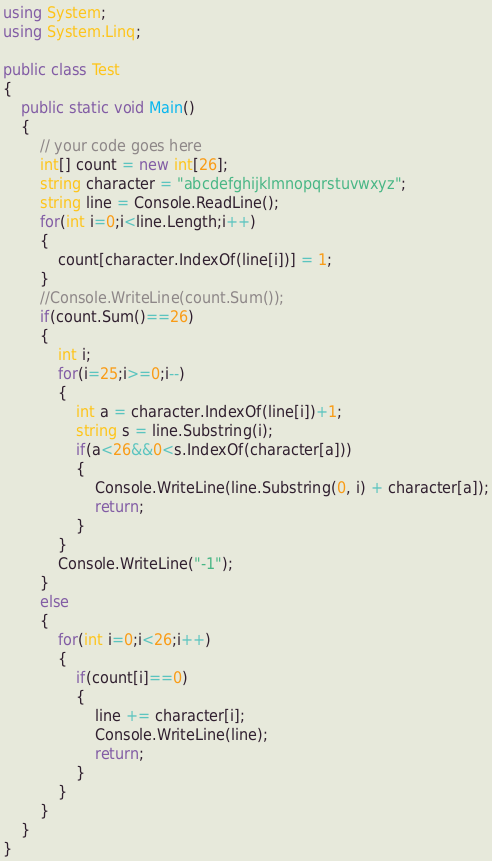<code> <loc_0><loc_0><loc_500><loc_500><_C#_>using System;
using System.Linq;
 
public class Test
{
	public static void Main()
	{
		// your code goes here
		int[] count = new int[26];
		string character = "abcdefghijklmnopqrstuvwxyz";
		string line = Console.ReadLine();
		for(int i=0;i<line.Length;i++)
		{
			count[character.IndexOf(line[i])] = 1;
		}
		//Console.WriteLine(count.Sum());
		if(count.Sum()==26)
		{
			int i;
			for(i=25;i>=0;i--)
			{
				int a = character.IndexOf(line[i])+1;
				string s = line.Substring(i);
				if(a<26&&0<s.IndexOf(character[a]))
				{
					Console.WriteLine(line.Substring(0, i) + character[a]);
					return;
				}
			}
			Console.WriteLine("-1");
		}
		else
		{
			for(int i=0;i<26;i++)
			{
				if(count[i]==0)
				{
					line += character[i];
					Console.WriteLine(line);
					return;
				}
			}
		}
	}
}
</code> 